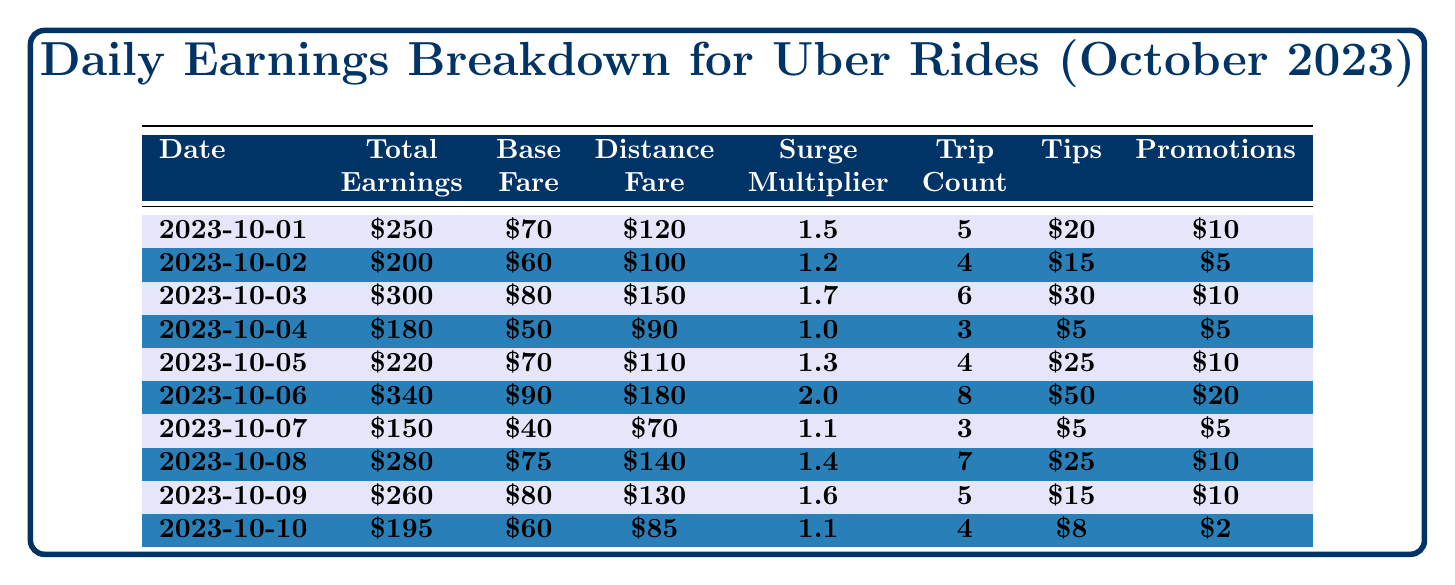What was the total earnings on October 6, 2023? The table shows that the total earnings on October 6, 2023, is listed directly under the 'Total Earnings' column for that date, which is \$340.
Answer: 340 How many trips did you make on October 4, 2023? The number of trips made on October 4, 2023, is directly available in the 'Trip Count' column for that date, which shows a value of 3.
Answer: 3 What was the surge multiplier for the ride on October 3, 2023? The surge multiplier for October 3, 2023, can be found under the 'Surge Multiplier' column, which indicates a value of 1.7.
Answer: 1.7 What is the average total earnings over the first five days of October 2023? To find the average, first, sum the total earnings from the first five days: (250 + 200 + 300 + 180 + 220) = 1150. Then, divide by 5, which gives 1150 / 5 = 230.
Answer: 230 Did you earn more than \$200 on October 08, 2023? On October 08, 2023, the total earnings displayed in the table is \$280. Since this amount is greater than \$200, the statement is true.
Answer: Yes What day had the highest earnings and what was the amount? By examining the 'Total Earnings' column for all dates, the highest value is \$340 on October 6, 2023. Hence, October 6 had the highest earnings.
Answer: October 6, 340 What is the total amount received in tips for the first week of October 2023? To calculate the total tips for the first week, sum the tip amounts for the first seven days: (20 + 15 + 30 + 5 + 25 + 50 + 5) = 150.
Answer: 150 What percentage of your total earnings on October 10, 2023, came from bonuses? The total earnings on October 10, 2023, is \$195, and the bonuses received that day were \$2. To find the percentage, divide the bonuses by total earnings and multiply by 100: (2 / 195) × 100 ≈ 1.03%.
Answer: 1.03% How much did you earn from distance fare on October 2, 2023? The amount earned from distance fare on October 2, 2023, is presented in the 'Distance Fare' column, which shows a value of \$100.
Answer: 100 On which date did you earn \$250? By reviewing the 'Total Earnings' column, we find that the date corresponding to \$250 is October 1, 2023.
Answer: October 1, 2023 